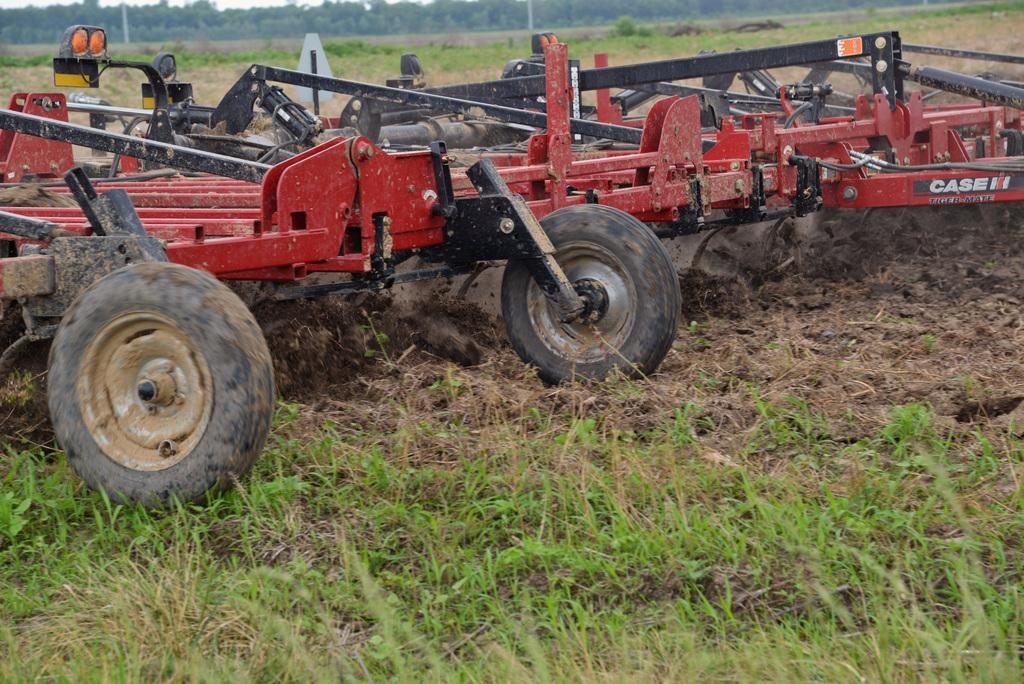What type of vehicle is on the path in the image? There is a red color tractor on the path in the image. What type of vegetation can be seen in the image? There are plants, grass, and trees in the image. What is attached to a pole in the image? There is a board attached to a pole in the image. What part of the natural environment is visible in the image? The sky is visible in the image. Can you see a cat playing with a doll near the stream in the image? There is no cat, doll, or stream present in the image. 